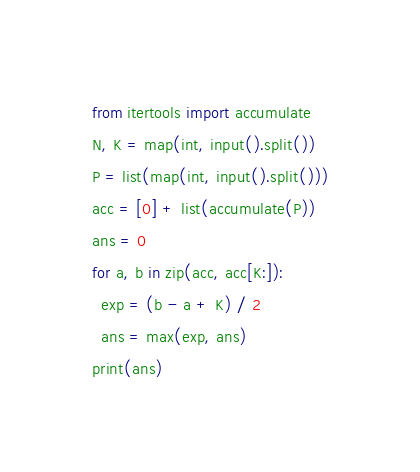<code> <loc_0><loc_0><loc_500><loc_500><_Python_>from itertools import accumulate
N, K = map(int, input().split())
P = list(map(int, input().split()))
acc = [0] + list(accumulate(P))
ans = 0
for a, b in zip(acc, acc[K:]):
  exp = (b - a + K) / 2
  ans = max(exp, ans)
print(ans)</code> 